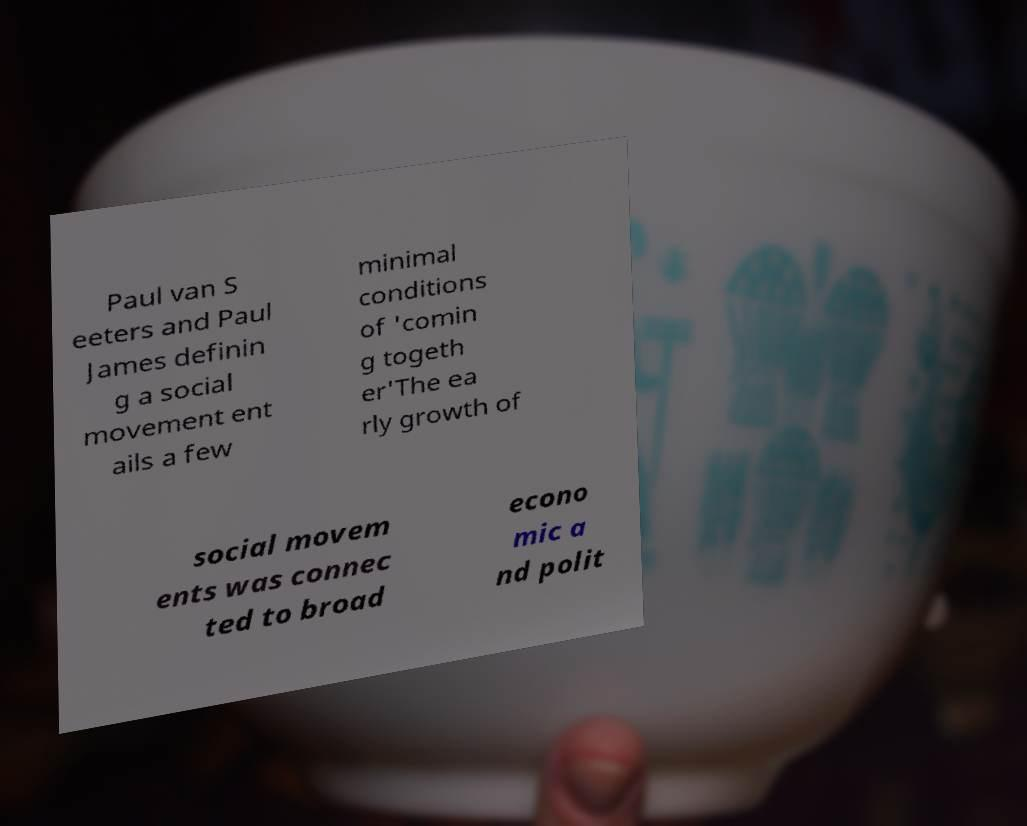Could you assist in decoding the text presented in this image and type it out clearly? Paul van S eeters and Paul James definin g a social movement ent ails a few minimal conditions of 'comin g togeth er'The ea rly growth of social movem ents was connec ted to broad econo mic a nd polit 